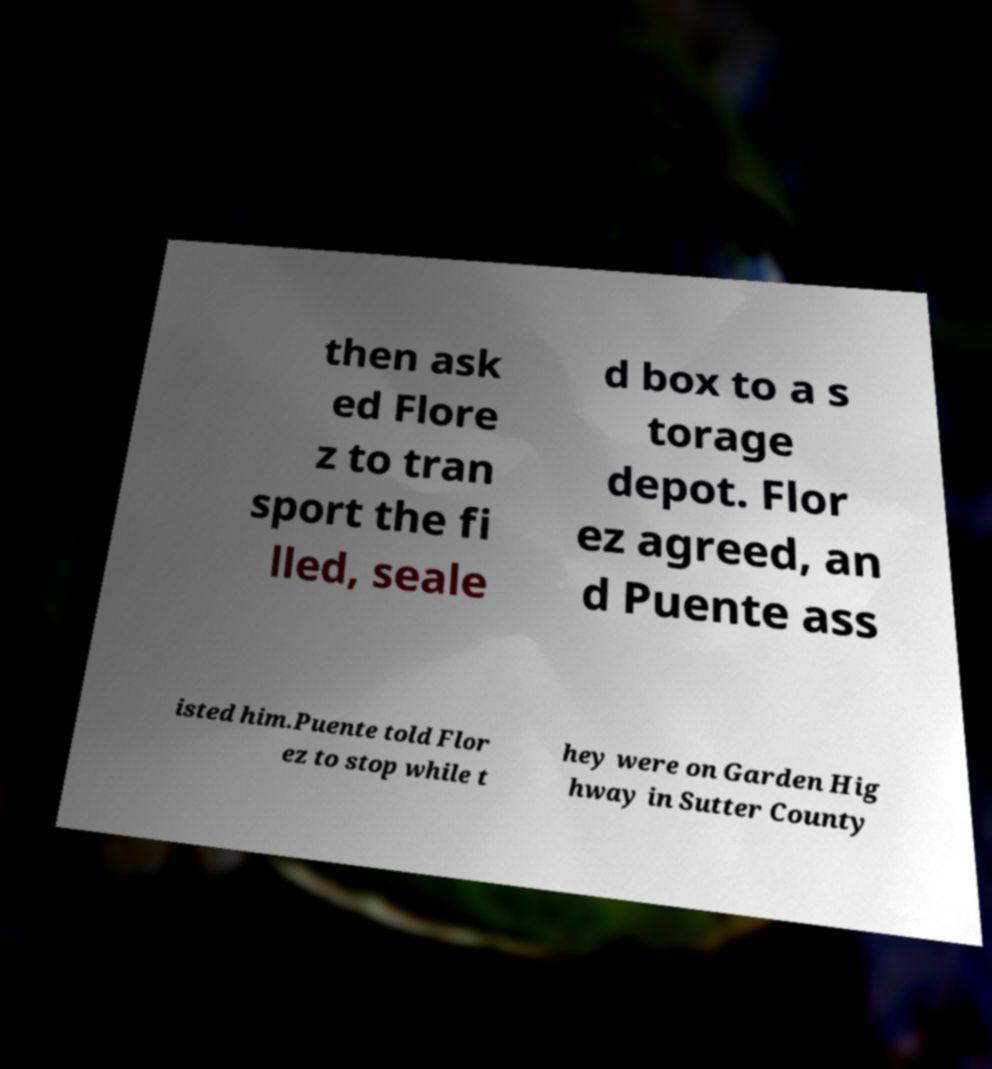Can you read and provide the text displayed in the image?This photo seems to have some interesting text. Can you extract and type it out for me? then ask ed Flore z to tran sport the fi lled, seale d box to a s torage depot. Flor ez agreed, an d Puente ass isted him.Puente told Flor ez to stop while t hey were on Garden Hig hway in Sutter County 